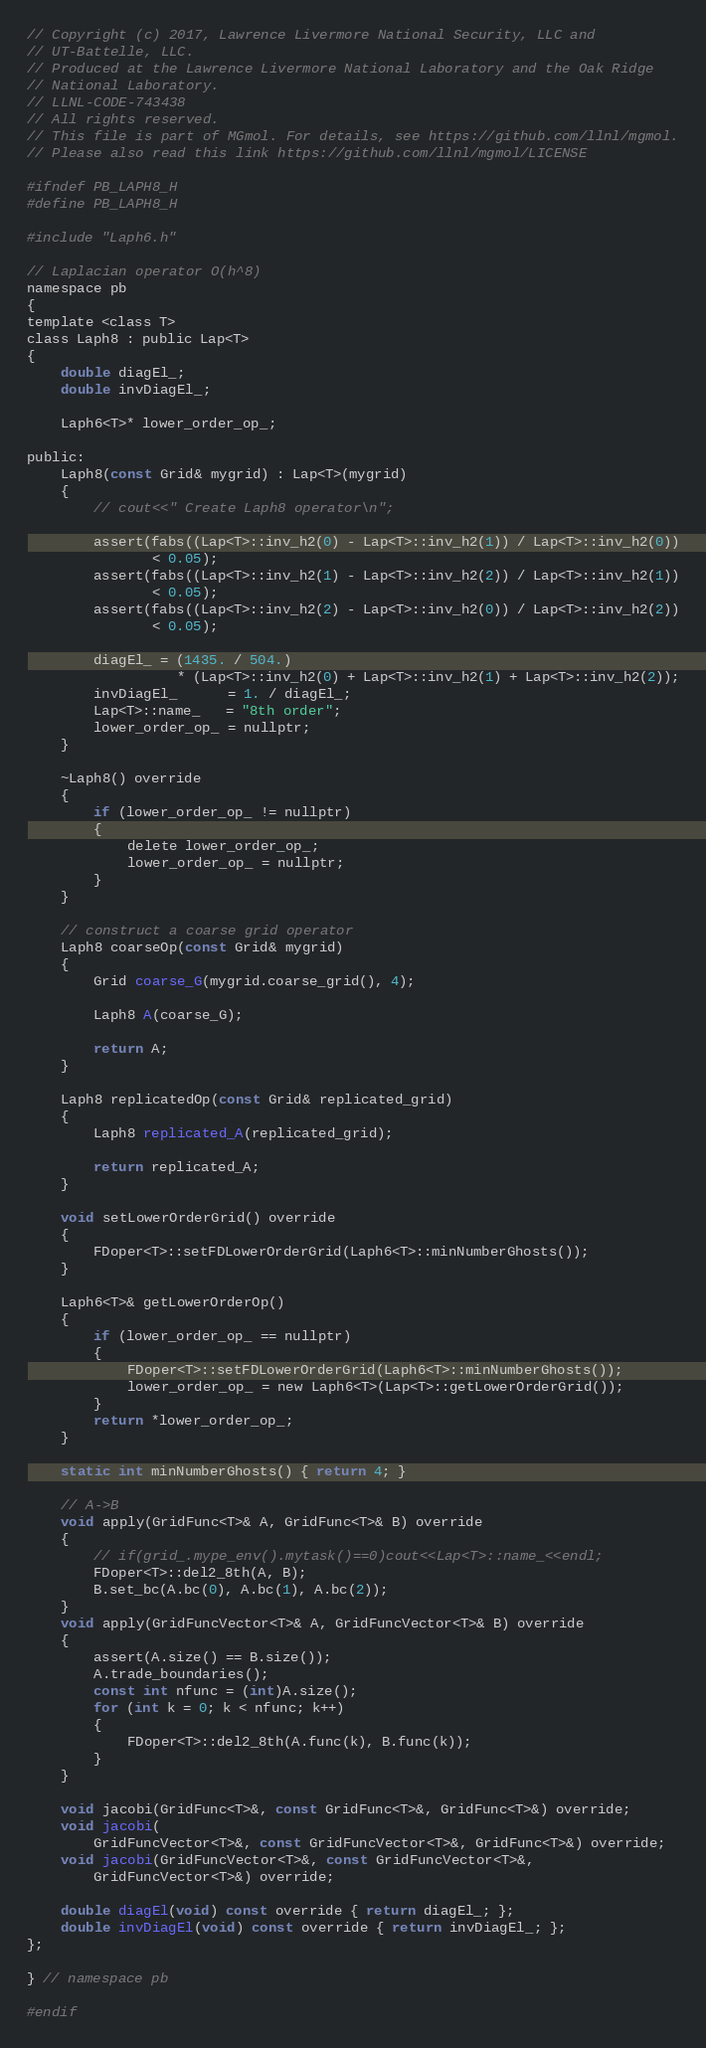<code> <loc_0><loc_0><loc_500><loc_500><_C_>// Copyright (c) 2017, Lawrence Livermore National Security, LLC and
// UT-Battelle, LLC.
// Produced at the Lawrence Livermore National Laboratory and the Oak Ridge
// National Laboratory.
// LLNL-CODE-743438
// All rights reserved.
// This file is part of MGmol. For details, see https://github.com/llnl/mgmol.
// Please also read this link https://github.com/llnl/mgmol/LICENSE

#ifndef PB_LAPH8_H
#define PB_LAPH8_H

#include "Laph6.h"

// Laplacian operator O(h^8)
namespace pb
{
template <class T>
class Laph8 : public Lap<T>
{
    double diagEl_;
    double invDiagEl_;

    Laph6<T>* lower_order_op_;

public:
    Laph8(const Grid& mygrid) : Lap<T>(mygrid)
    {
        // cout<<" Create Laph8 operator\n";

        assert(fabs((Lap<T>::inv_h2(0) - Lap<T>::inv_h2(1)) / Lap<T>::inv_h2(0))
               < 0.05);
        assert(fabs((Lap<T>::inv_h2(1) - Lap<T>::inv_h2(2)) / Lap<T>::inv_h2(1))
               < 0.05);
        assert(fabs((Lap<T>::inv_h2(2) - Lap<T>::inv_h2(0)) / Lap<T>::inv_h2(2))
               < 0.05);

        diagEl_ = (1435. / 504.)
                  * (Lap<T>::inv_h2(0) + Lap<T>::inv_h2(1) + Lap<T>::inv_h2(2));
        invDiagEl_      = 1. / diagEl_;
        Lap<T>::name_   = "8th order";
        lower_order_op_ = nullptr;
    }

    ~Laph8() override
    {
        if (lower_order_op_ != nullptr)
        {
            delete lower_order_op_;
            lower_order_op_ = nullptr;
        }
    }

    // construct a coarse grid operator
    Laph8 coarseOp(const Grid& mygrid)
    {
        Grid coarse_G(mygrid.coarse_grid(), 4);

        Laph8 A(coarse_G);

        return A;
    }

    Laph8 replicatedOp(const Grid& replicated_grid)
    {
        Laph8 replicated_A(replicated_grid);

        return replicated_A;
    }

    void setLowerOrderGrid() override
    {
        FDoper<T>::setFDLowerOrderGrid(Laph6<T>::minNumberGhosts());
    }

    Laph6<T>& getLowerOrderOp()
    {
        if (lower_order_op_ == nullptr)
        {
            FDoper<T>::setFDLowerOrderGrid(Laph6<T>::minNumberGhosts());
            lower_order_op_ = new Laph6<T>(Lap<T>::getLowerOrderGrid());
        }
        return *lower_order_op_;
    }

    static int minNumberGhosts() { return 4; }

    // A->B
    void apply(GridFunc<T>& A, GridFunc<T>& B) override
    {
        // if(grid_.mype_env().mytask()==0)cout<<Lap<T>::name_<<endl;
        FDoper<T>::del2_8th(A, B);
        B.set_bc(A.bc(0), A.bc(1), A.bc(2));
    }
    void apply(GridFuncVector<T>& A, GridFuncVector<T>& B) override
    {
        assert(A.size() == B.size());
        A.trade_boundaries();
        const int nfunc = (int)A.size();
        for (int k = 0; k < nfunc; k++)
        {
            FDoper<T>::del2_8th(A.func(k), B.func(k));
        }
    }

    void jacobi(GridFunc<T>&, const GridFunc<T>&, GridFunc<T>&) override;
    void jacobi(
        GridFuncVector<T>&, const GridFuncVector<T>&, GridFunc<T>&) override;
    void jacobi(GridFuncVector<T>&, const GridFuncVector<T>&,
        GridFuncVector<T>&) override;

    double diagEl(void) const override { return diagEl_; };
    double invDiagEl(void) const override { return invDiagEl_; };
};

} // namespace pb

#endif
</code> 